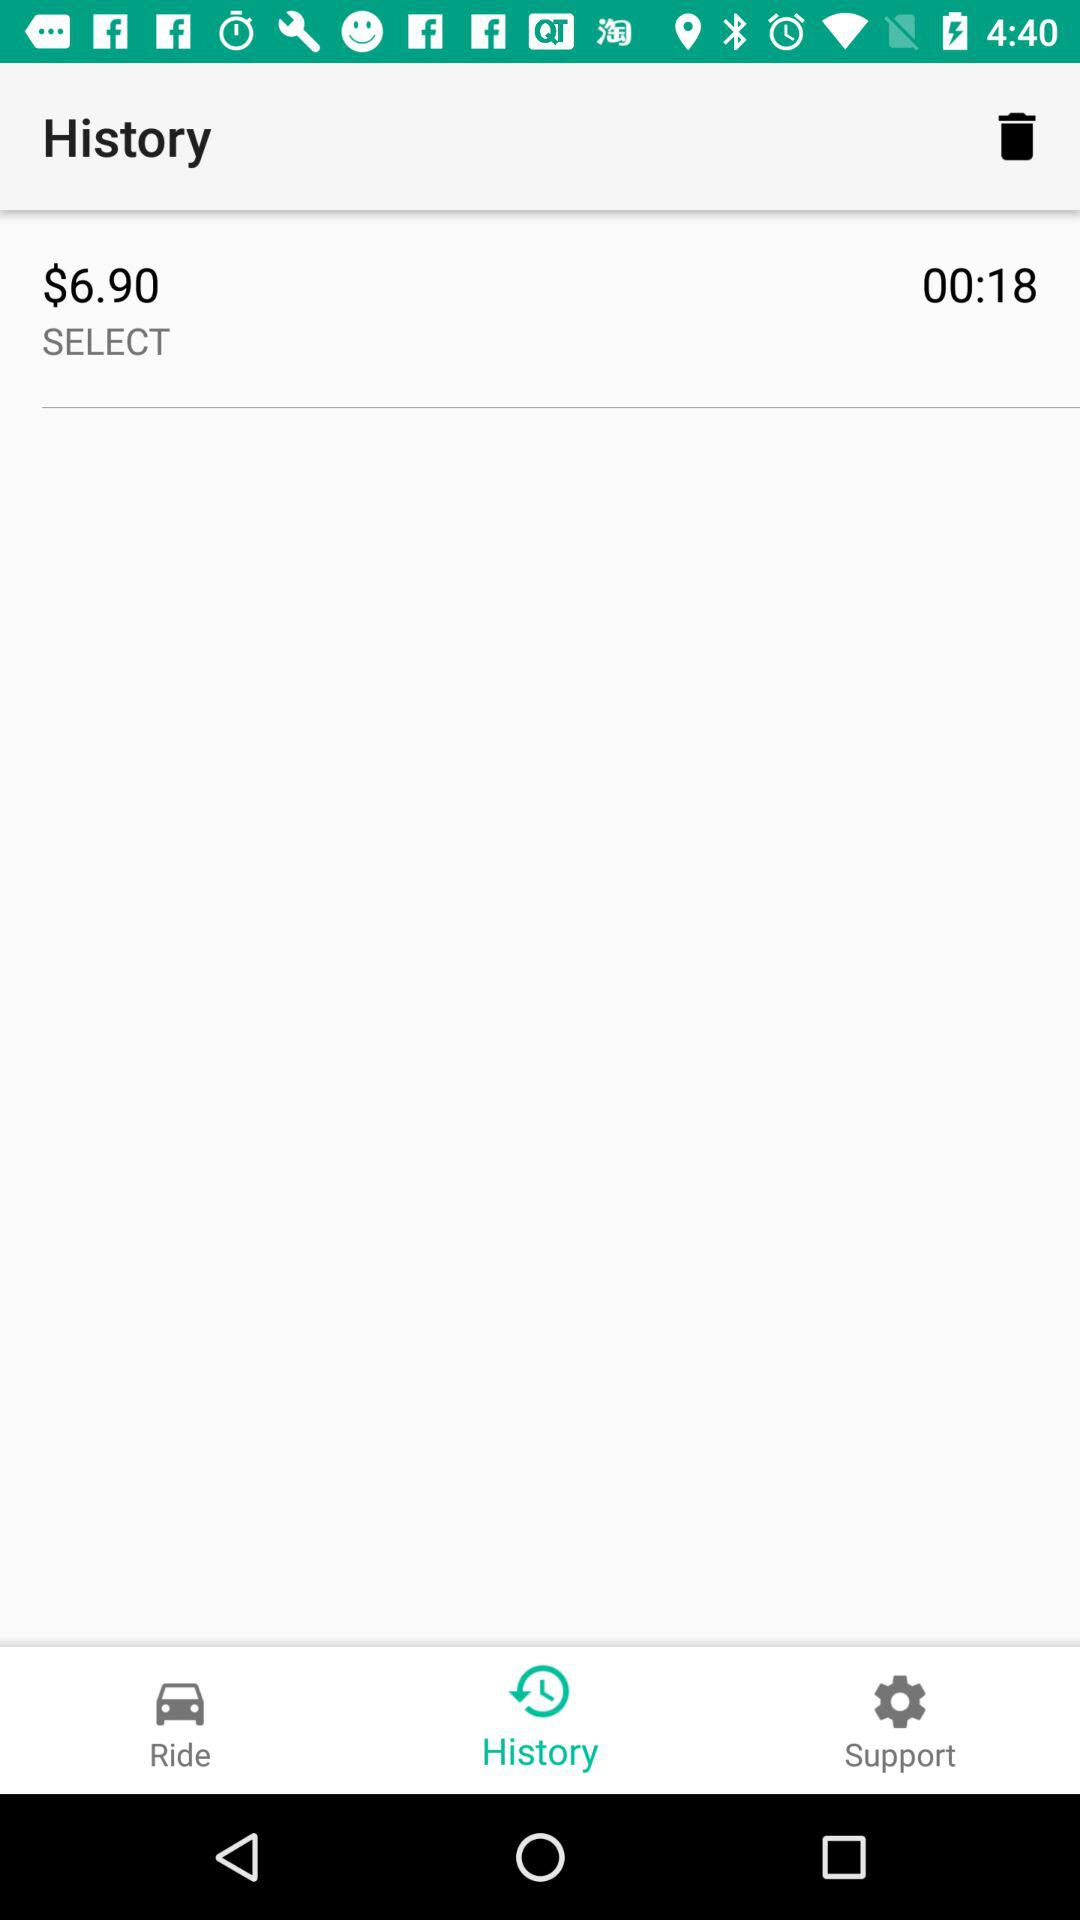How long is the ride?
Answer the question using a single word or phrase. 00:18 